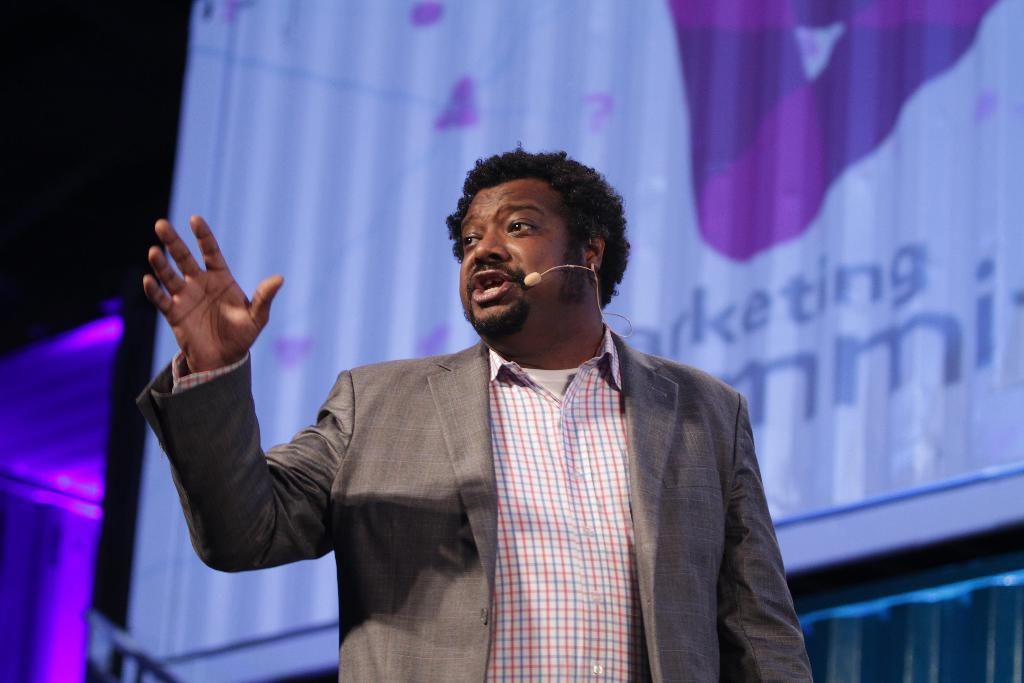What is the person in the image doing? There is a person talking in the image. What can be seen in the background of the image? There is a screen in the background. What type of wilderness can be seen in the background of the image? There is no wilderness present in the image; it features a person talking and a screen in the background. What type of wing is visible on the person in the image? There is no wing present on the person in the image. 